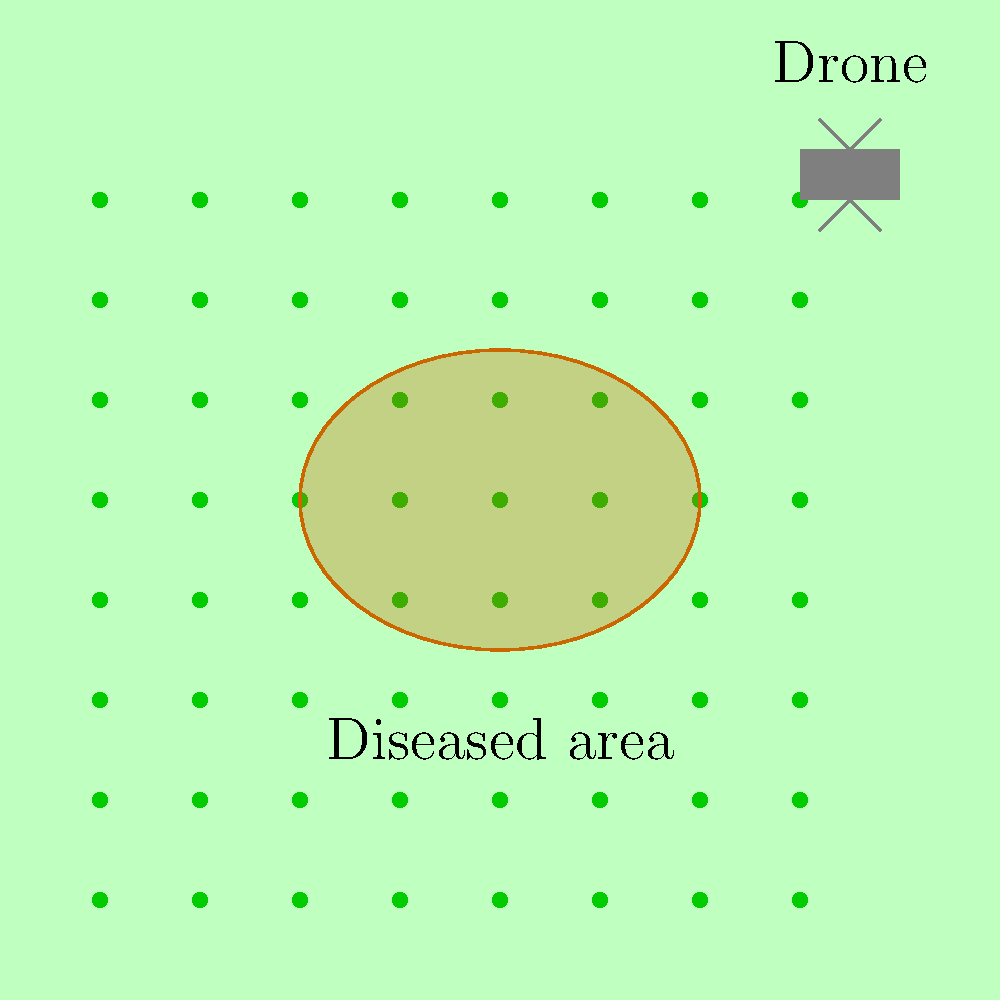As a rice farmer using drone technology to monitor your fields, you notice a circular pattern of discoloration in your latest aerial images. What machine learning technique would be most appropriate for automatically detecting and classifying these potential disease outbreaks in your rice crop? To answer this question, let's consider the problem step-by-step:

1. The task involves analyzing visual data (drone-captured images) to detect and classify disease outbreaks.

2. The patterns we're looking for (circular discolorations) have specific visual characteristics that distinguish them from healthy crops.

3. We need a machine learning technique that can:
   a) Process and analyze image data
   b) Identify specific patterns or features within images
   c) Classify regions of the image based on these features

4. Given these requirements, the most appropriate machine learning technique would be Convolutional Neural Networks (CNNs).

5. CNNs are particularly well-suited for this task because:
   a) They are designed to work with grid-like data, such as images
   b) They can automatically learn relevant features from the image data
   c) They can detect patterns at different scales, which is useful for identifying disease outbreaks of varying sizes
   d) They can be trained to classify different types of plant diseases based on visual cues

6. The process would involve:
   a) Collecting a large dataset of drone images, including both healthy and diseased crops
   b) Labeling the images to indicate diseased areas
   c) Training a CNN on this dataset
   d) Using the trained CNN to analyze new drone images and automatically detect potential disease outbreaks

7. This approach would allow for efficient, large-scale monitoring of rice fields, enabling early detection and treatment of diseases to maintain high-quality rice production.
Answer: Convolutional Neural Networks (CNNs) 